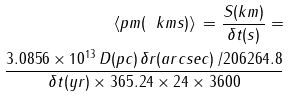Convert formula to latex. <formula><loc_0><loc_0><loc_500><loc_500>\left < p m ( \ k m s ) \right > \, = \frac { S ( k m ) } { \delta t ( s ) } = \\ \frac { 3 . 0 8 5 6 \times 1 0 ^ { 1 3 } \, D ( p c ) \, \delta r ( a r c s e c ) \, / 2 0 6 2 6 4 . 8 } { \delta t ( y r ) \times 3 6 5 . 2 4 \times 2 4 \times 3 6 0 0 }</formula> 